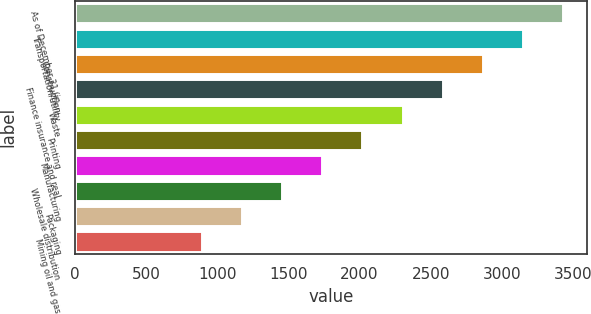Convert chart to OTSL. <chart><loc_0><loc_0><loc_500><loc_500><bar_chart><fcel>As of December 31 (in<fcel>Transportation/utility<fcel>Construction<fcel>Finance insurance and real<fcel>Waste<fcel>Printing<fcel>Manufacturing<fcel>Wholesale distribution<fcel>Packaging<fcel>Mining oil and gas<nl><fcel>3428.22<fcel>3146.86<fcel>2865.5<fcel>2584.14<fcel>2302.78<fcel>2021.42<fcel>1740.06<fcel>1458.7<fcel>1177.34<fcel>895.98<nl></chart> 